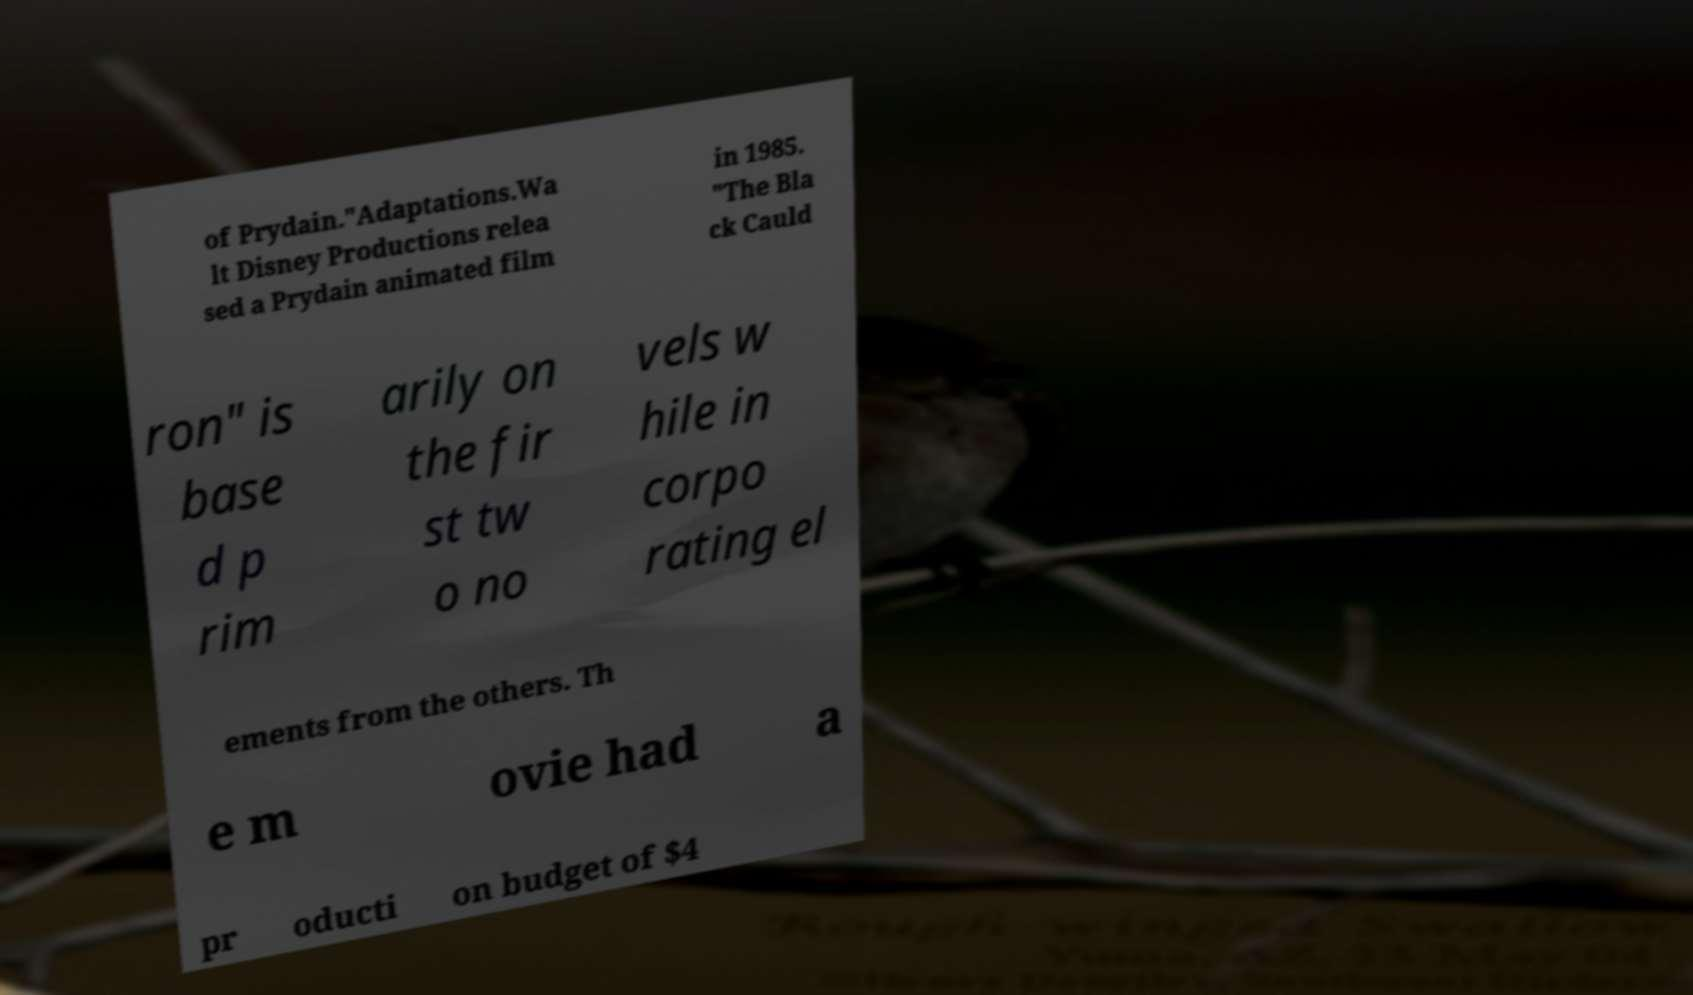What messages or text are displayed in this image? I need them in a readable, typed format. of Prydain."Adaptations.Wa lt Disney Productions relea sed a Prydain animated film in 1985. "The Bla ck Cauld ron" is base d p rim arily on the fir st tw o no vels w hile in corpo rating el ements from the others. Th e m ovie had a pr oducti on budget of $4 